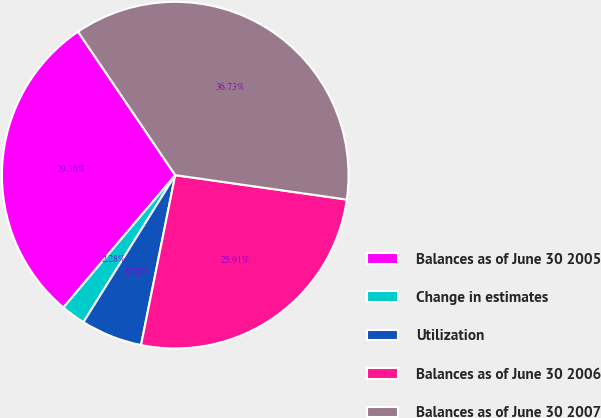<chart> <loc_0><loc_0><loc_500><loc_500><pie_chart><fcel>Balances as of June 30 2005<fcel>Change in estimates<fcel>Utilization<fcel>Balances as of June 30 2006<fcel>Balances as of June 30 2007<nl><fcel>29.36%<fcel>2.28%<fcel>5.72%<fcel>25.91%<fcel>36.73%<nl></chart> 